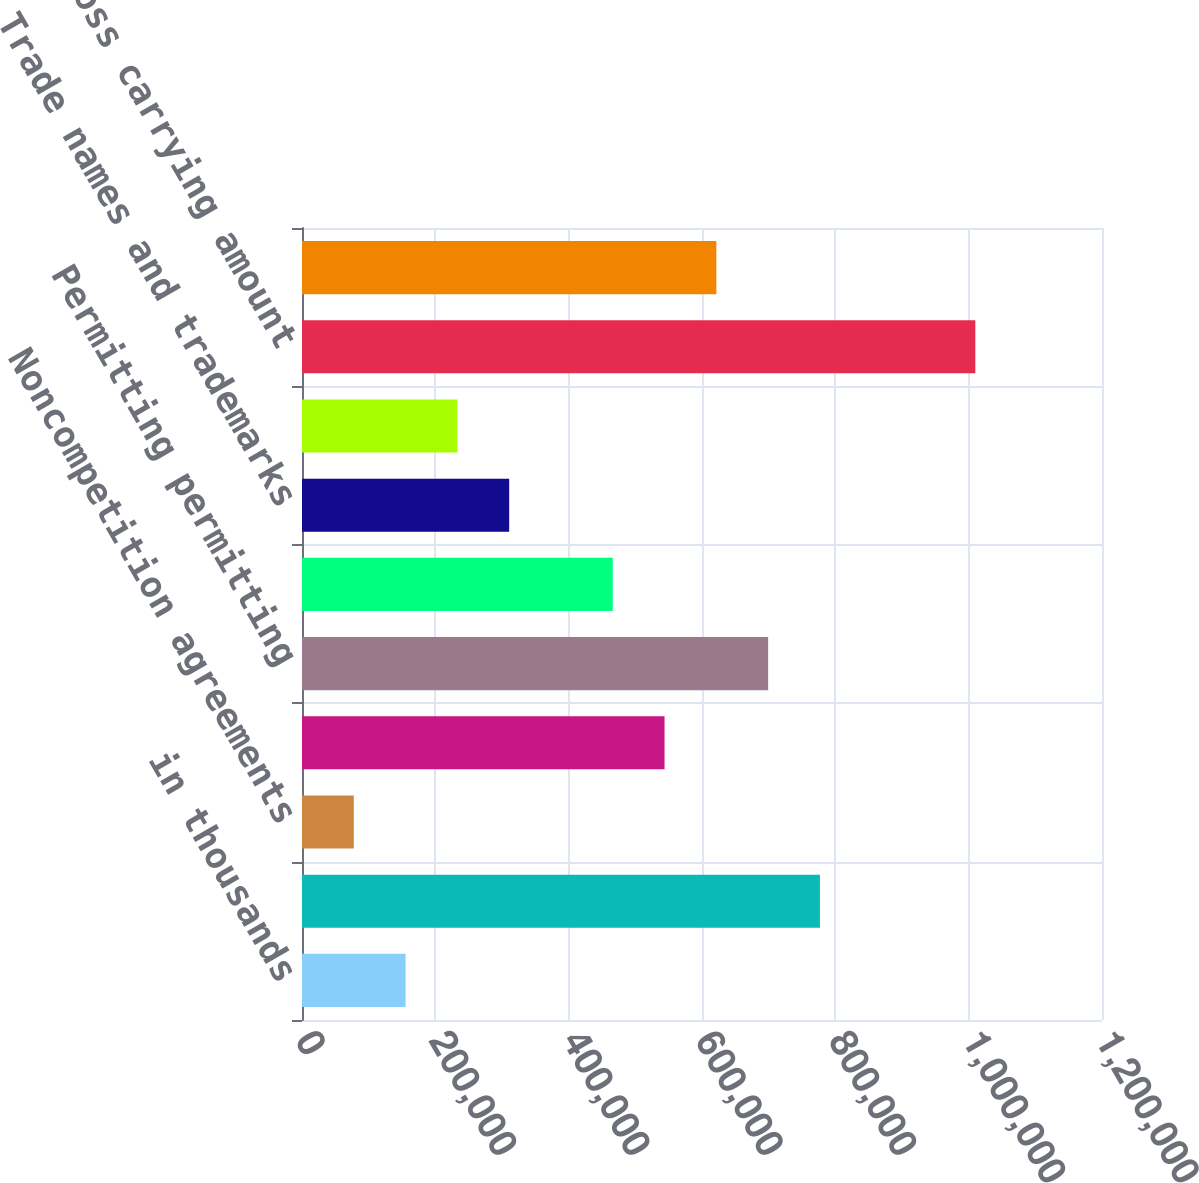Convert chart. <chart><loc_0><loc_0><loc_500><loc_500><bar_chart><fcel>in thousands<fcel>Contractual rights in place<fcel>Noncompetition agreements<fcel>Favorable lease agreements<fcel>Permitting permitting<fcel>Customer relationships<fcel>Trade names and trademarks<fcel>Other<fcel>Total gross carrying amount<fcel>Total accumulated amortization<nl><fcel>155384<fcel>776909<fcel>77692.9<fcel>543837<fcel>699218<fcel>466146<fcel>310765<fcel>233074<fcel>1.00998e+06<fcel>621528<nl></chart> 